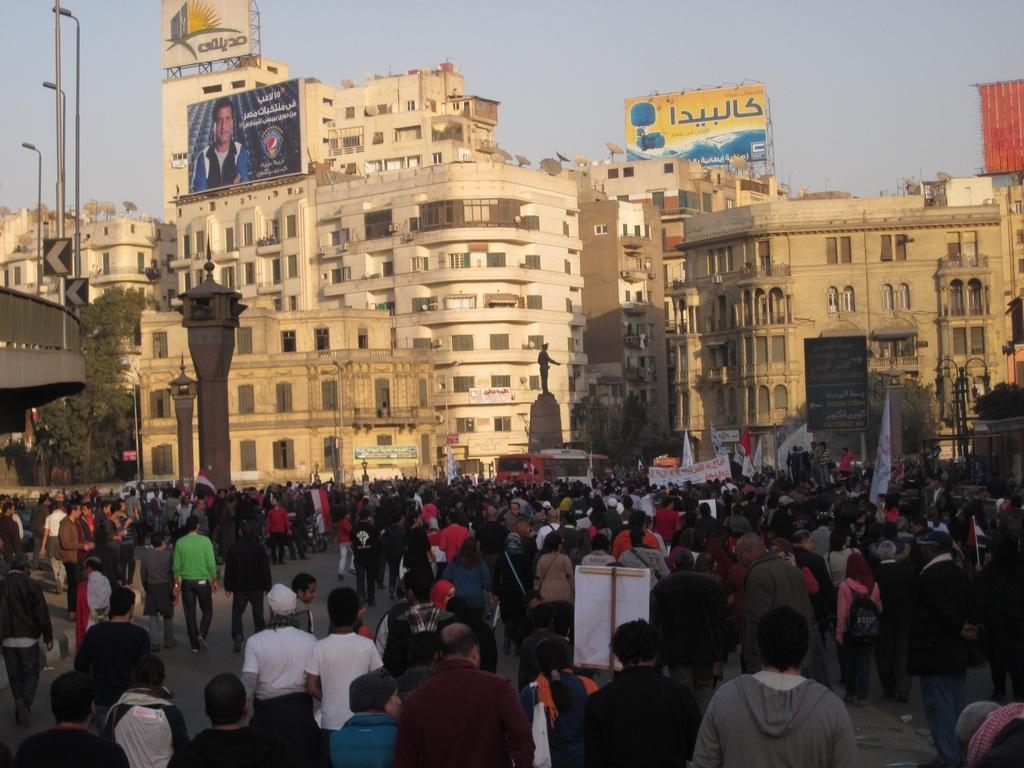Could you give a brief overview of what you see in this image? There are group of persons, some of them, holding hoardings and some of them holding banners, on the road. In the background, there are buildings, there are statues, a bridge, there are poles and there is a sky. 